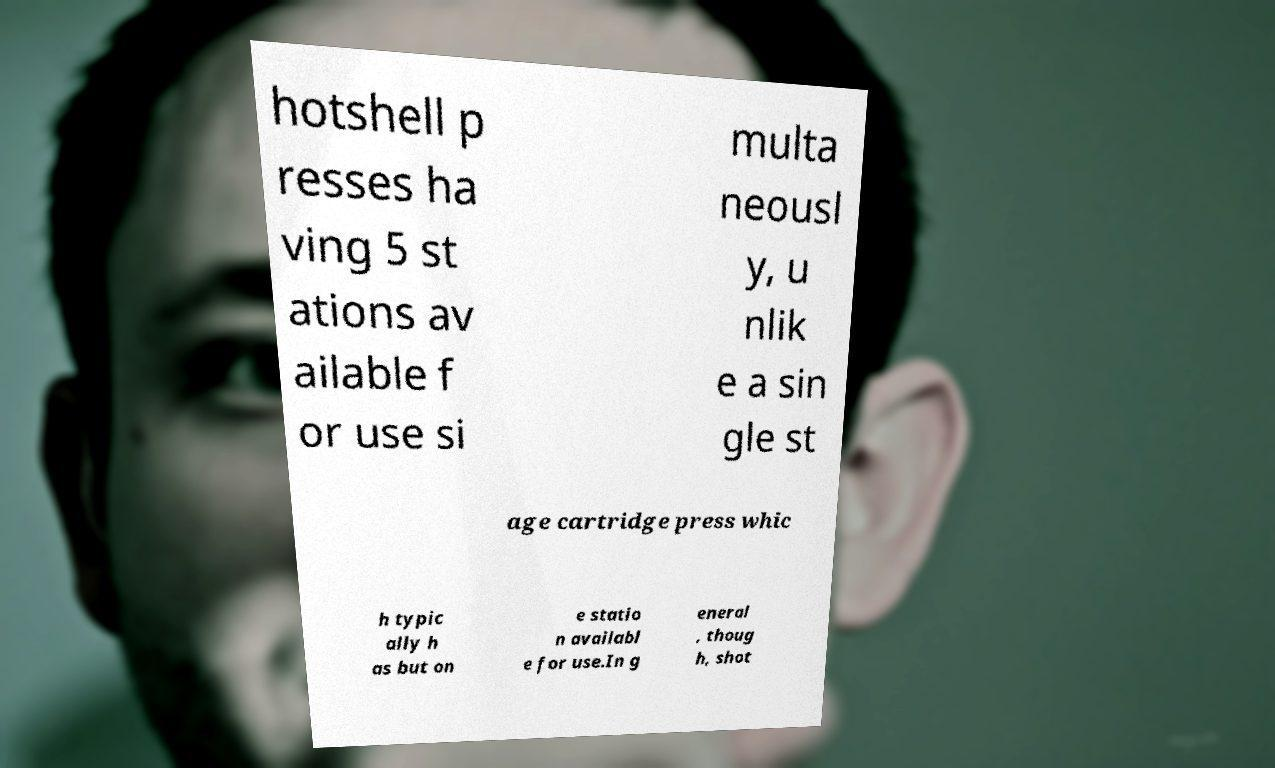Please read and relay the text visible in this image. What does it say? hotshell p resses ha ving 5 st ations av ailable f or use si multa neousl y, u nlik e a sin gle st age cartridge press whic h typic ally h as but on e statio n availabl e for use.In g eneral , thoug h, shot 